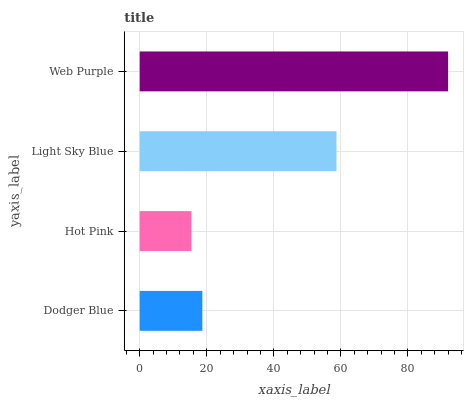Is Hot Pink the minimum?
Answer yes or no. Yes. Is Web Purple the maximum?
Answer yes or no. Yes. Is Light Sky Blue the minimum?
Answer yes or no. No. Is Light Sky Blue the maximum?
Answer yes or no. No. Is Light Sky Blue greater than Hot Pink?
Answer yes or no. Yes. Is Hot Pink less than Light Sky Blue?
Answer yes or no. Yes. Is Hot Pink greater than Light Sky Blue?
Answer yes or no. No. Is Light Sky Blue less than Hot Pink?
Answer yes or no. No. Is Light Sky Blue the high median?
Answer yes or no. Yes. Is Dodger Blue the low median?
Answer yes or no. Yes. Is Dodger Blue the high median?
Answer yes or no. No. Is Web Purple the low median?
Answer yes or no. No. 